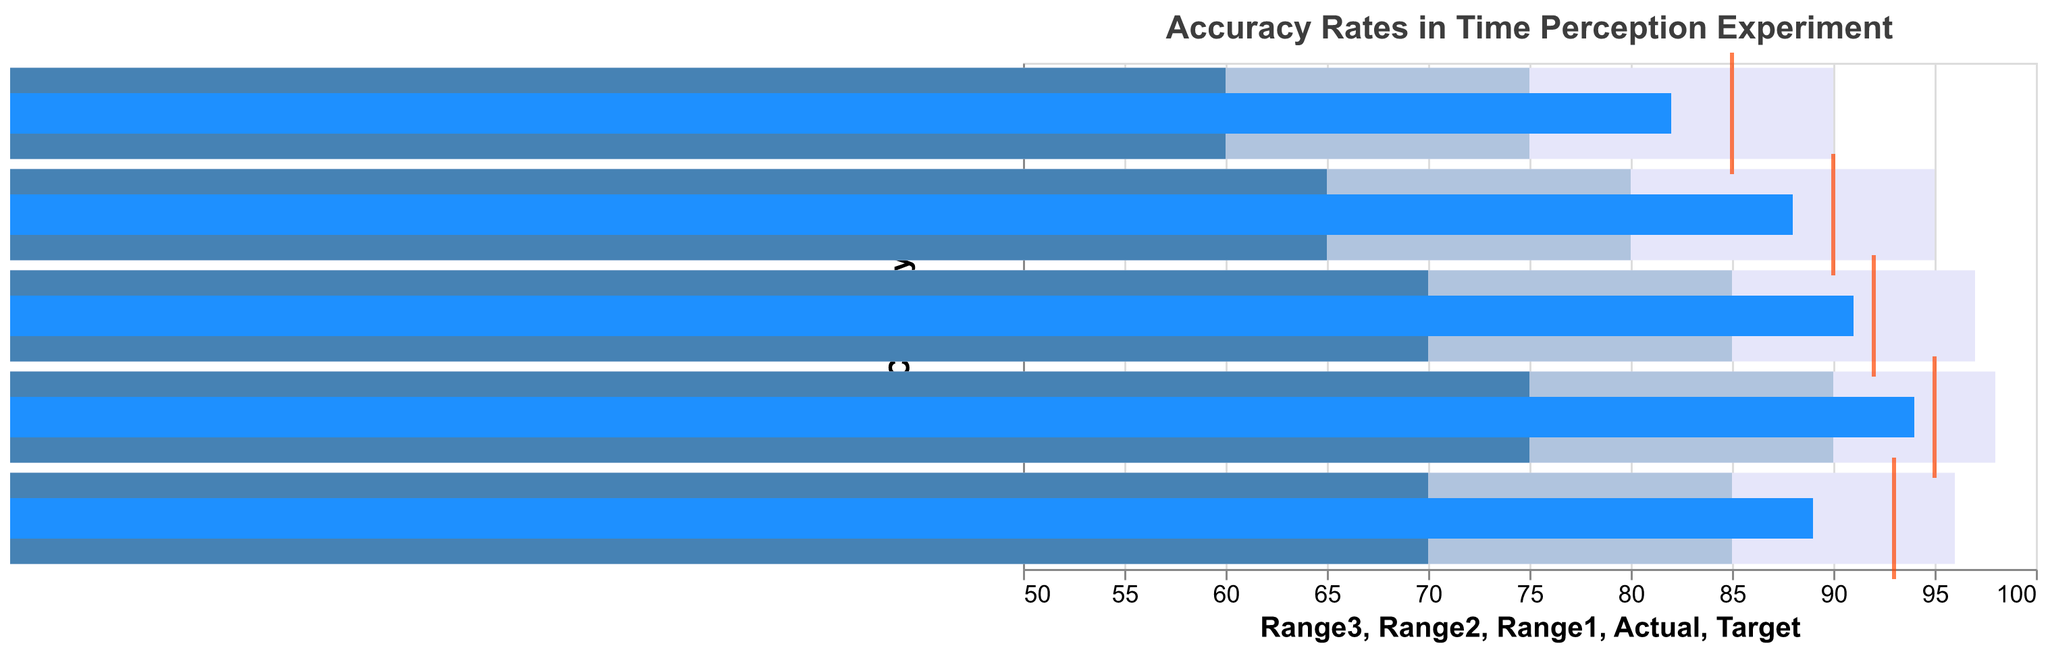What is the title of the chart? The title of the chart is clearly stated at the top of the figure.
Answer: "Accuracy Rates in Time Perception Experiment" What are the categories shown on the y-axis? The categories are listed along the y-axis of the bullet chart. They represent different interval durations in milliseconds.
Answer: "100ms, 250ms, 500ms, 1000ms, 2000ms" What color represents the 'Actual' accuracy rates in the chart? The 'Actual' accuracy rates are depicted with a specific color bar in the bullet chart. It is identified by the legend or visual differentiation.
Answer: Blue Which interval duration has the lowest 'Actual' accuracy rate? By examining the 'Actual' accuracy rates for all interval durations, the smallest value can be identified.
Answer: "100ms" What is the difference between the 'Target' and 'Actual' rate for the 2000ms interval? Locate the 'Target' and 'Actual' accuracy rates for the 2000ms interval on the chart and subtract the 'Actual' from the 'Target'.
Answer: 4 Which interval duration most closely meets its 'Target' rate? Compare the 'Actual' and 'Target' accuracy rates for each interval duration, finding the smallest difference between the two.
Answer: "500ms" How many categories have an 'Actual' accuracy rate higher than their midpoint range (Range2)? Count the number of categories where the 'Actual' accuracy rate bar exceeds the midpoint range (Range2) for each interval duration.
Answer: 3 Which interval duration exceeds the 'Target' accuracy rate the most? Determine the difference between the 'Actual' and 'Target' accuracy rates for each category and find the maximum positive difference.
Answer: "1000ms" Does any interval duration fail to meet the lower range (Range1)? Check each category to see if the 'Actual' rate falls below the minimum range (Range1).
Answer: No 